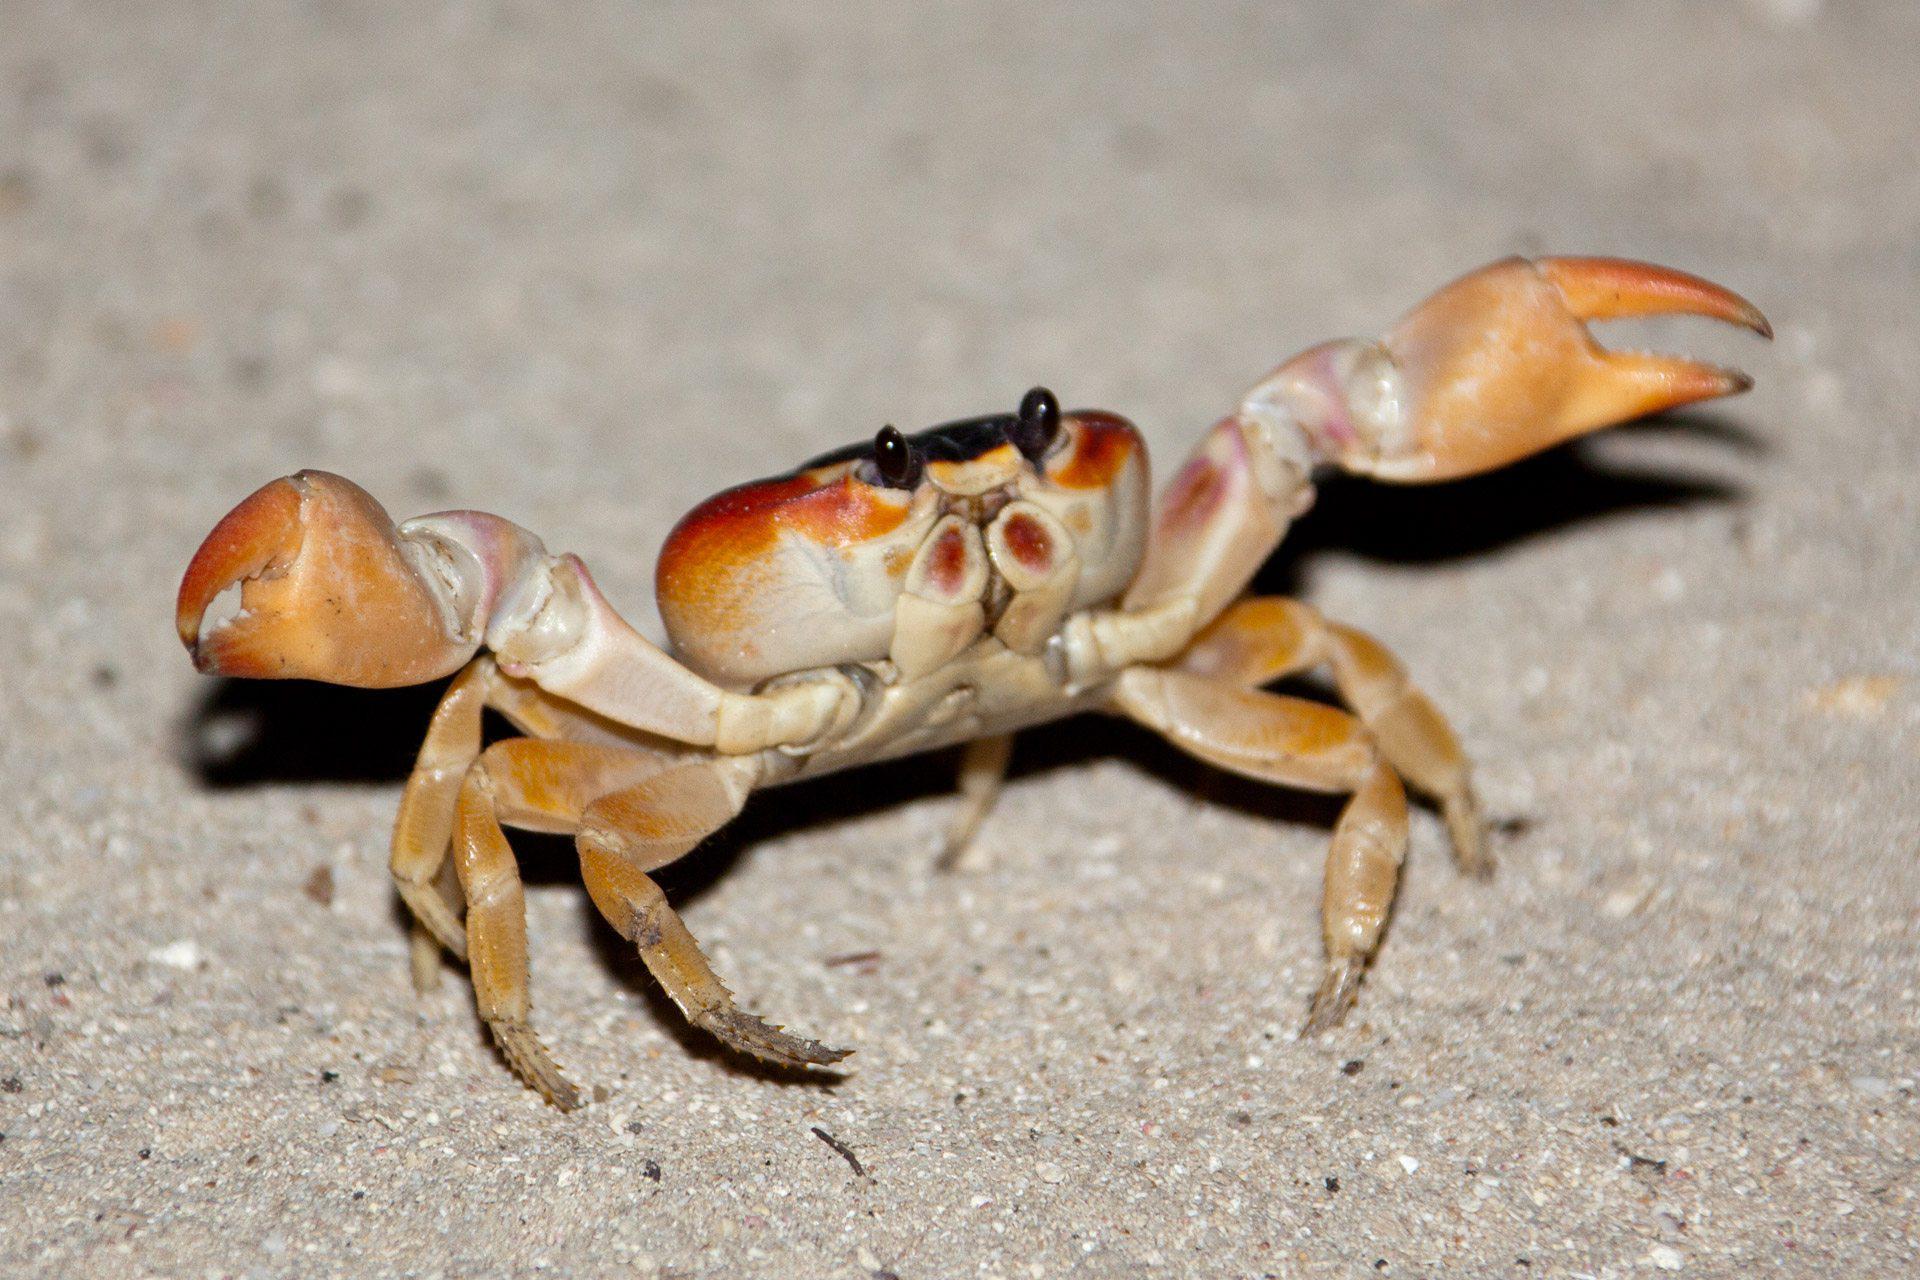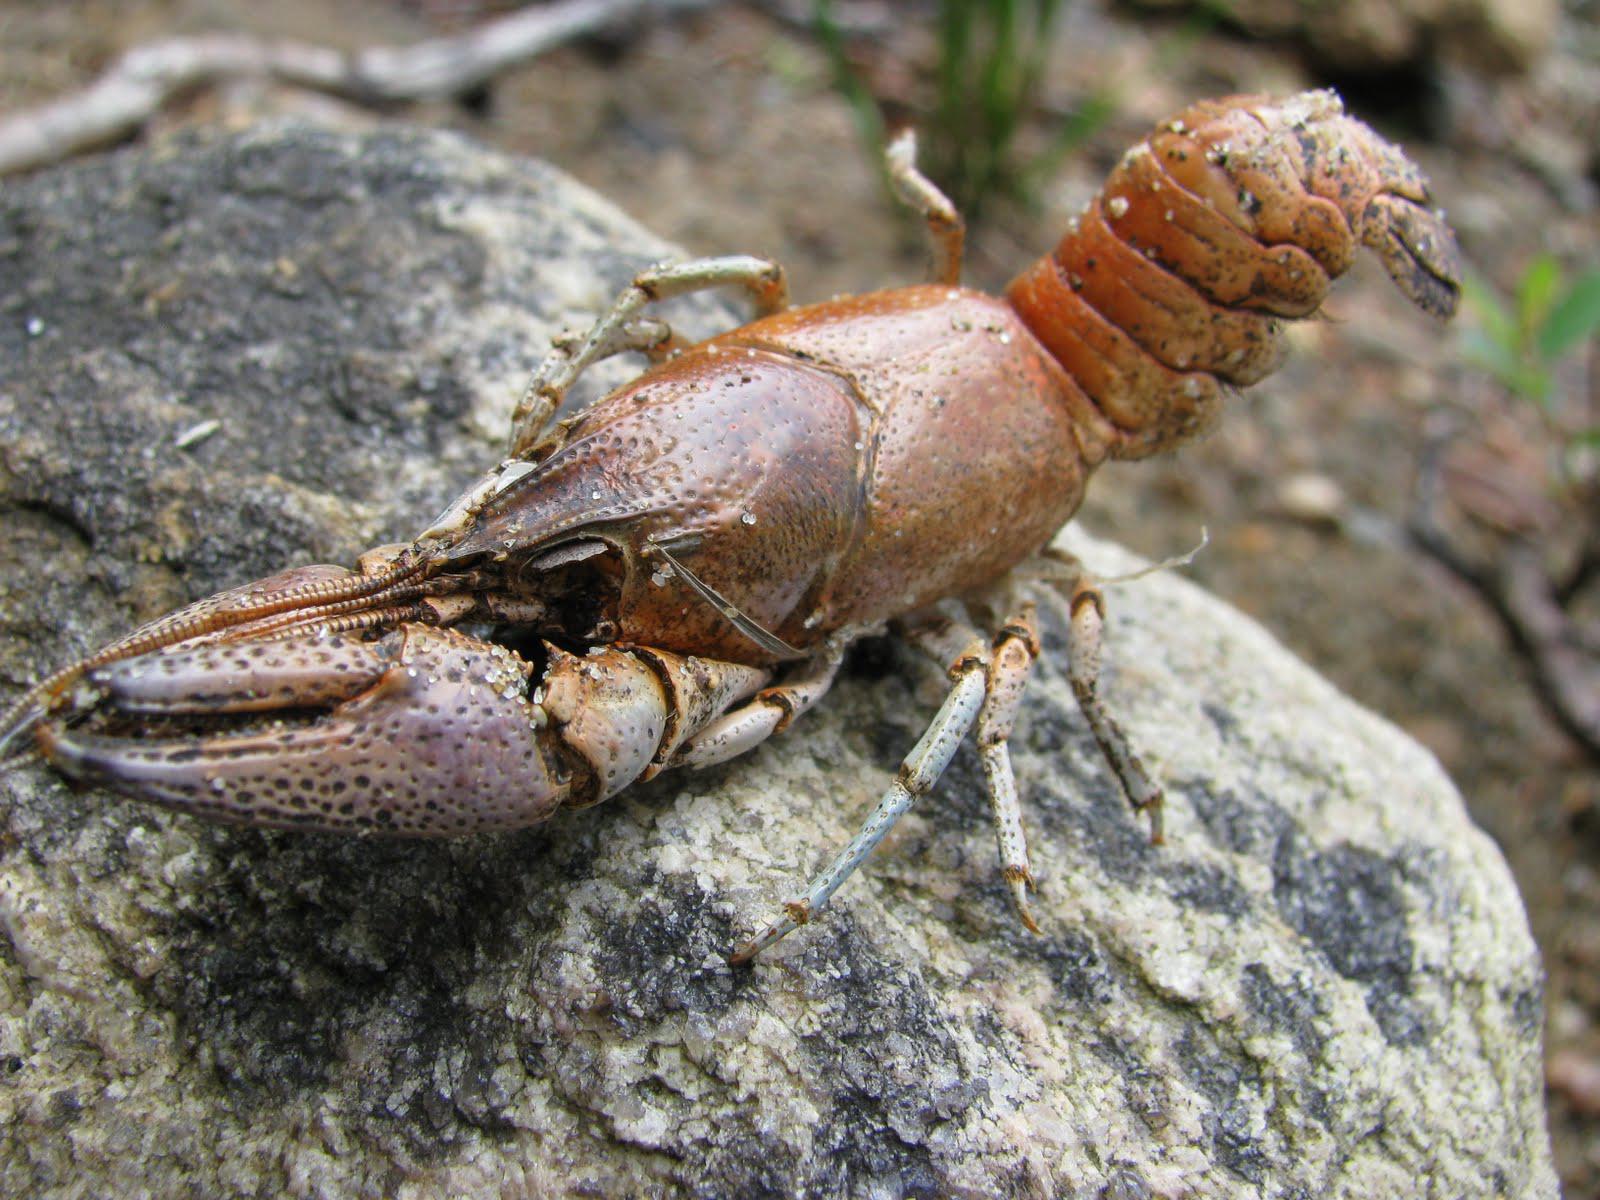The first image is the image on the left, the second image is the image on the right. Examine the images to the left and right. Is the description "The righthand image shows a blue-and-yellow faced crab with its two red front claws turned downward and perched on rock." accurate? Answer yes or no. No. 